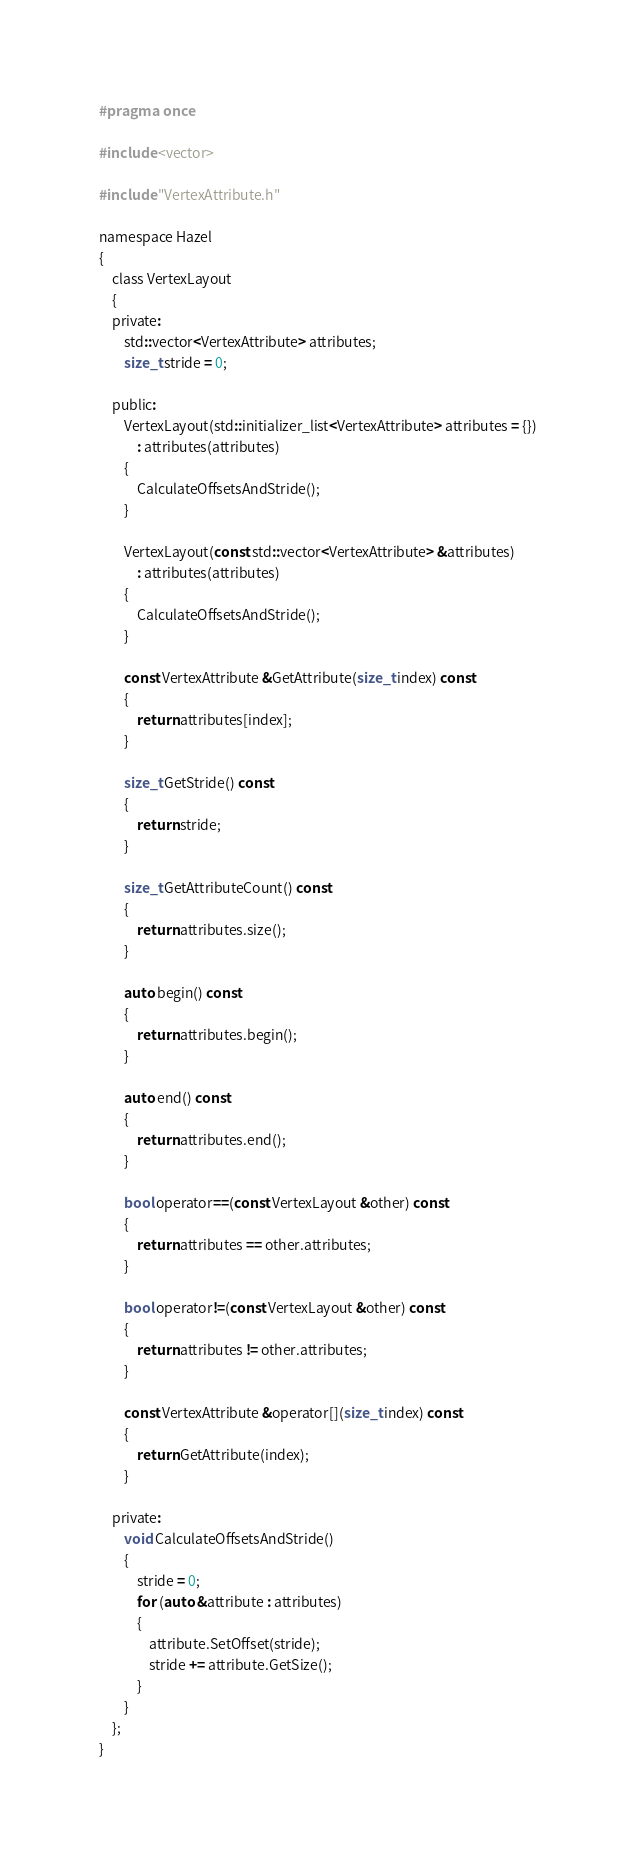Convert code to text. <code><loc_0><loc_0><loc_500><loc_500><_C_>#pragma once

#include <vector>

#include "VertexAttribute.h"

namespace Hazel
{
	class VertexLayout
	{
	private:
		std::vector<VertexAttribute> attributes;
		size_t stride = 0;

	public:
		VertexLayout(std::initializer_list<VertexAttribute> attributes = {})
			: attributes(attributes)
		{
			CalculateOffsetsAndStride();
		}

		VertexLayout(const std::vector<VertexAttribute> &attributes)
			: attributes(attributes)
		{
			CalculateOffsetsAndStride();
		}

		const VertexAttribute &GetAttribute(size_t index) const
		{
			return attributes[index];
		}

		size_t GetStride() const
		{
			return stride;
		}

		size_t GetAttributeCount() const
		{
			return attributes.size();
		}

		auto begin() const
		{
			return attributes.begin();
		}

		auto end() const
		{
			return attributes.end();
		}

		bool operator==(const VertexLayout &other) const
		{
			return attributes == other.attributes;
		}

		bool operator!=(const VertexLayout &other) const
		{
			return attributes != other.attributes;
		}

		const VertexAttribute &operator[](size_t index) const
		{
			return GetAttribute(index);
		}

	private:
		void CalculateOffsetsAndStride()
		{
			stride = 0;
			for (auto &attribute : attributes)
			{
				attribute.SetOffset(stride);
				stride += attribute.GetSize();
			}
		}
	};
}</code> 